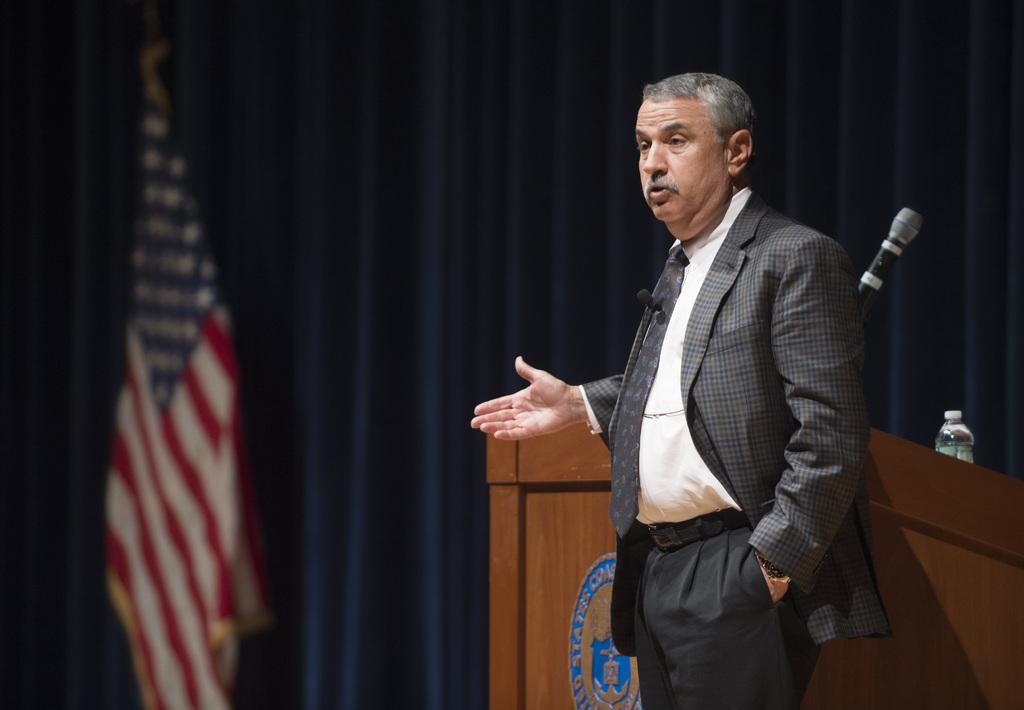In one or two sentences, can you explain what this image depicts? In this picture I can see a man standing, there is a mike and a water bottle on the podium, there is a flag, and in the background there are curtains. 